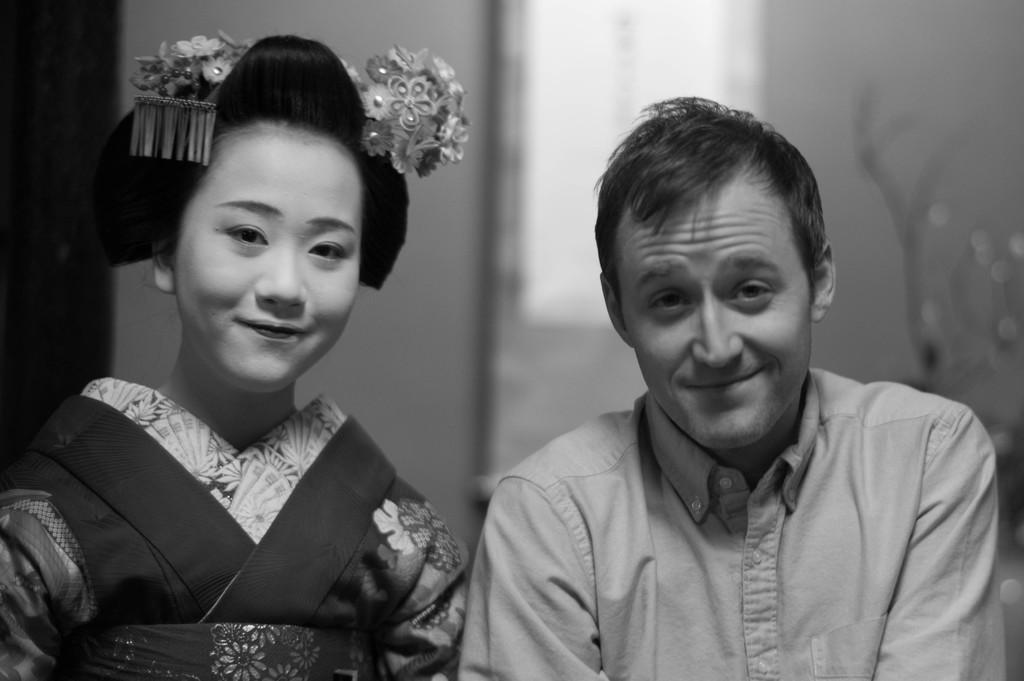How would you summarize this image in a sentence or two? In this image I can see two people are smiling. Background is blurred. The image is in black and white. 